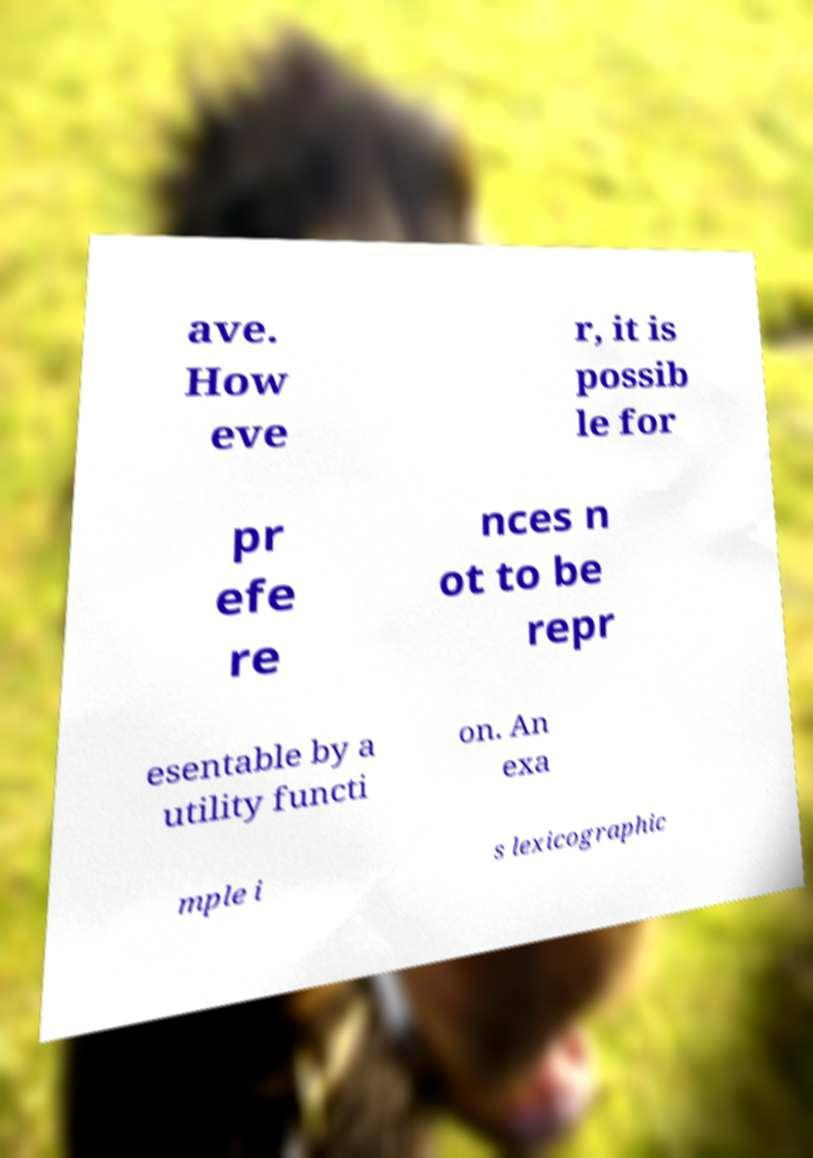Can you accurately transcribe the text from the provided image for me? ave. How eve r, it is possib le for pr efe re nces n ot to be repr esentable by a utility functi on. An exa mple i s lexicographic 